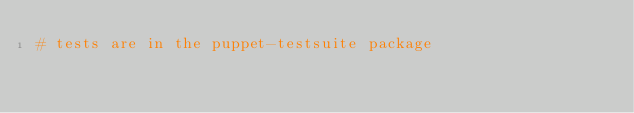<code> <loc_0><loc_0><loc_500><loc_500><_Ruby_># tests are in the puppet-testsuite package
</code> 